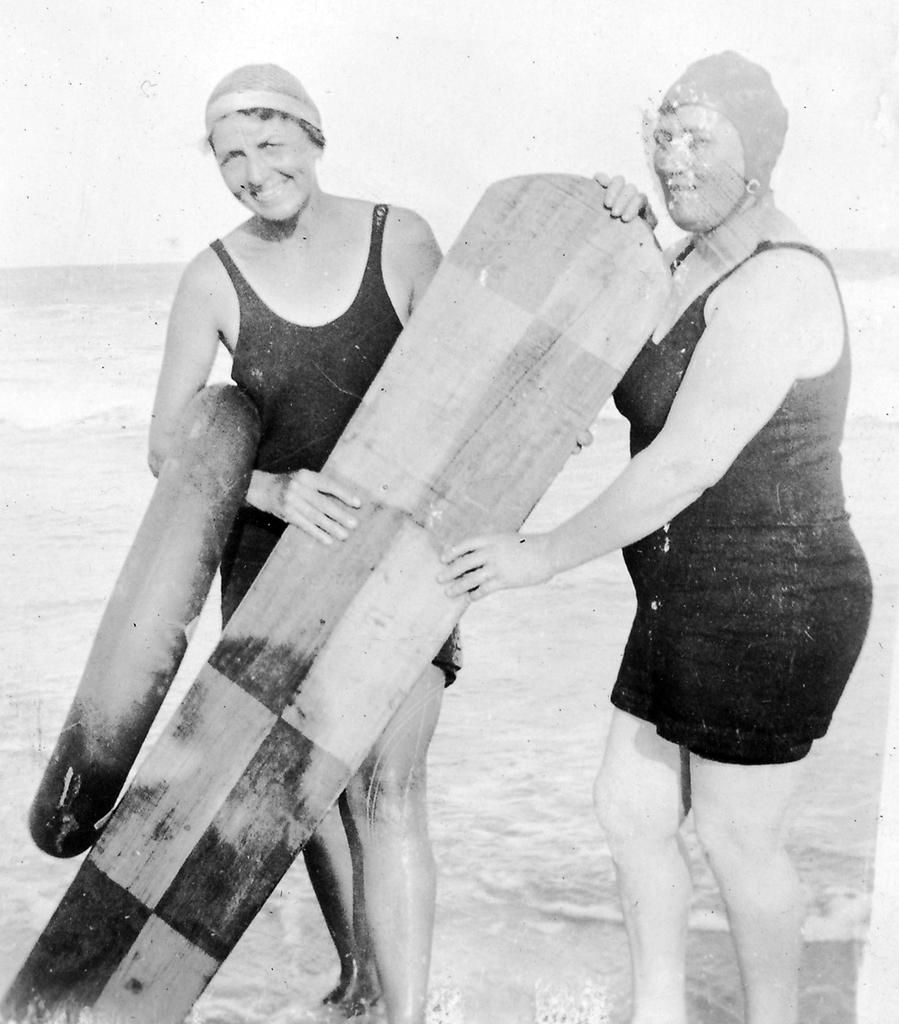How many people are in the image? There are two women in the image. What are the women holding in the image? The women are holding a surfboard. Where are the women standing in the image? The women are standing in the sand. What is the amount of steel used to construct the surfboard in the image? There is no information about the construction of the surfboard or the use of steel in the image. 